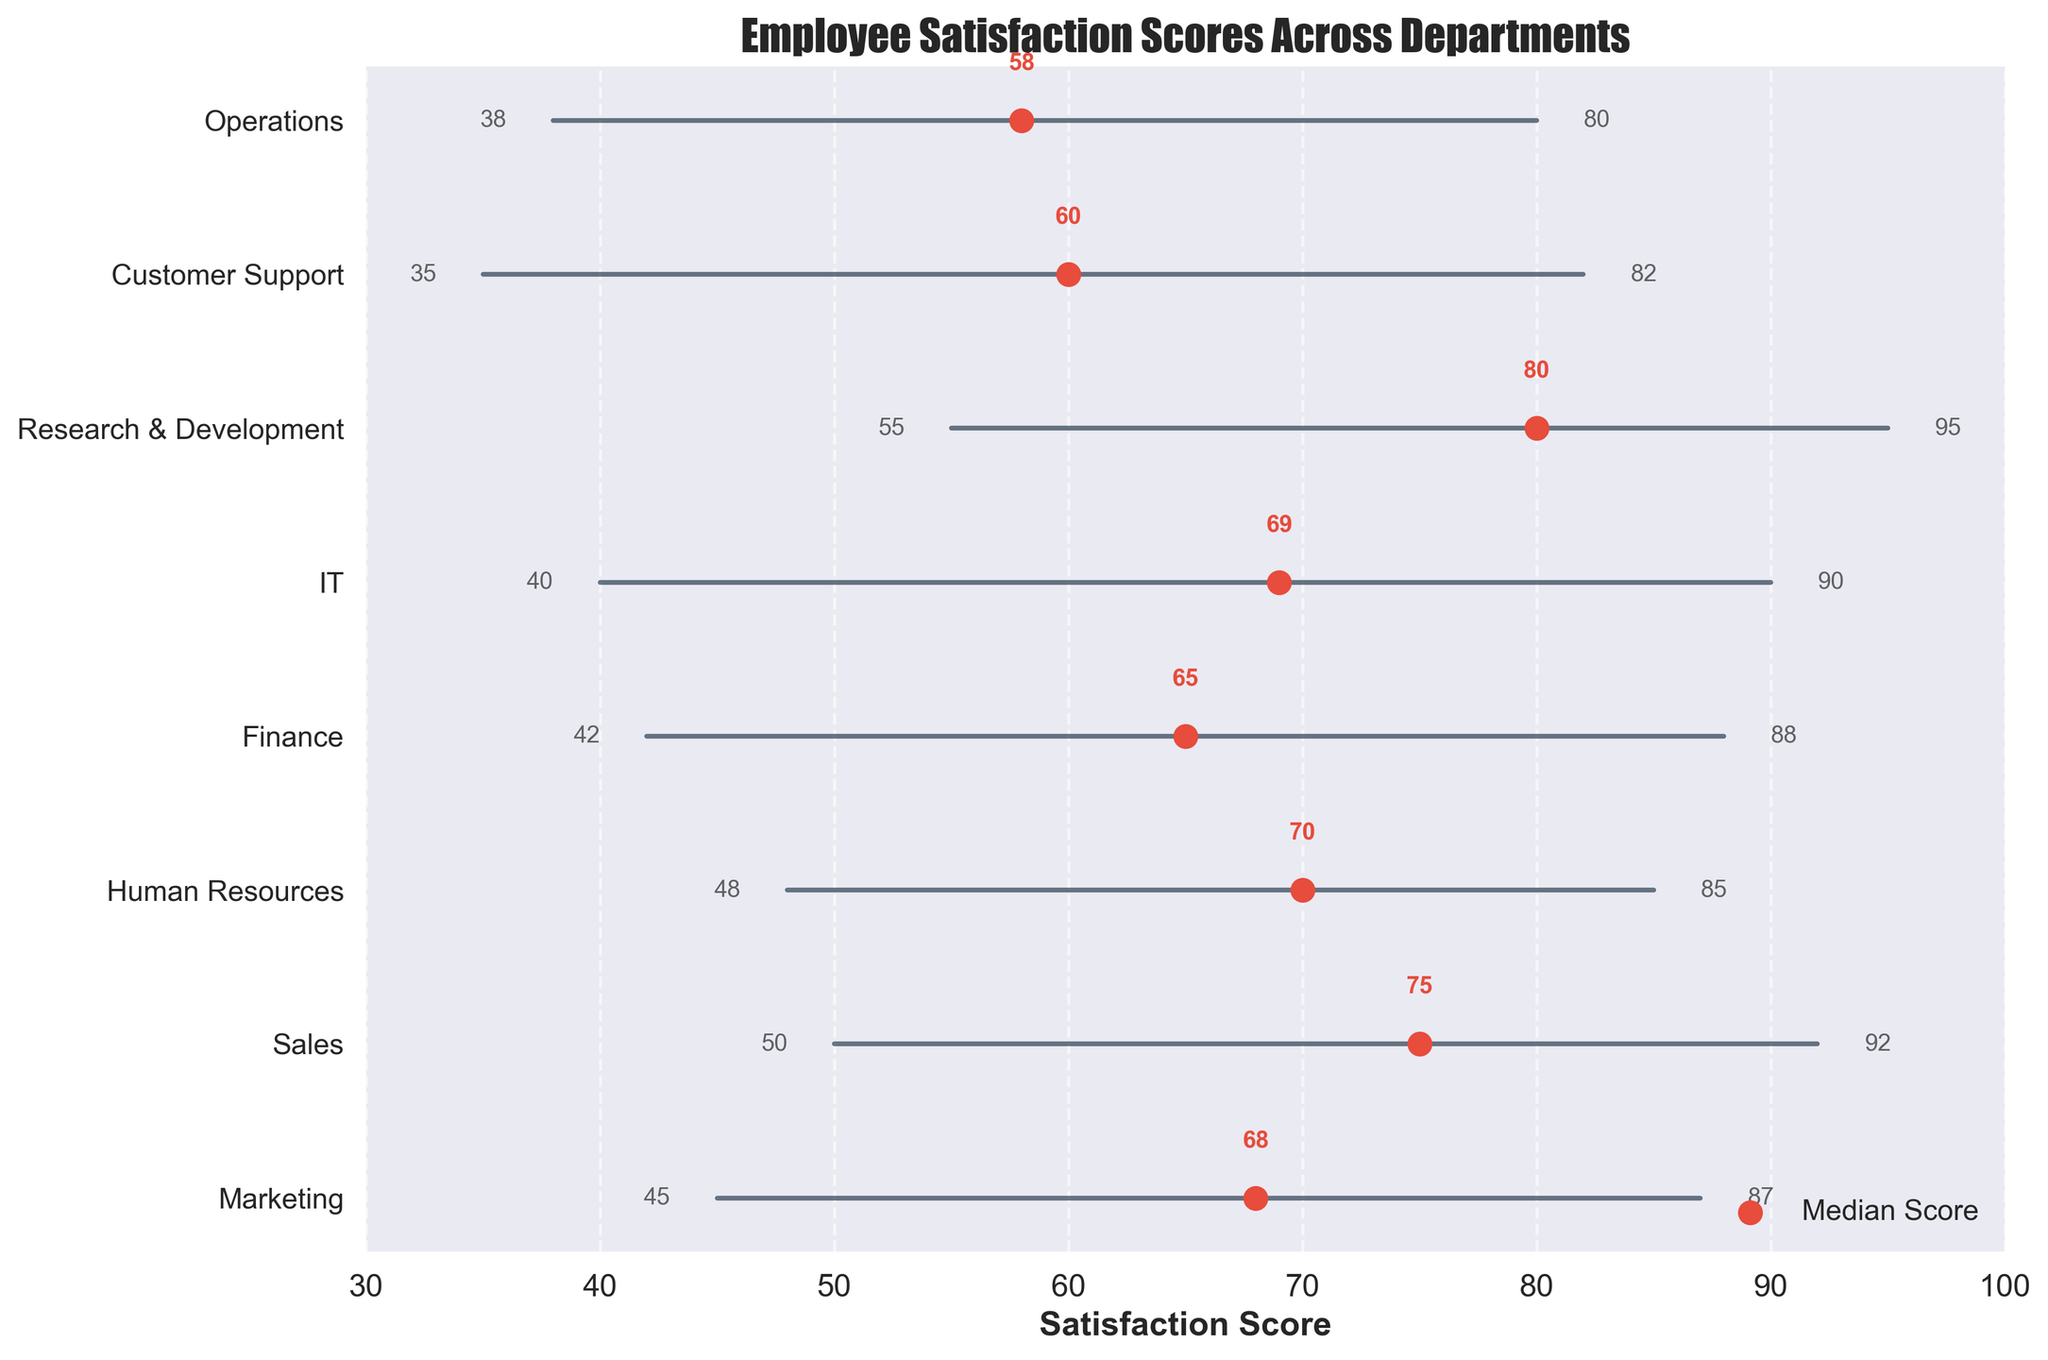Which department has the highest median employee satisfaction score? The department with the highest median score is the one whose red dot (representing the median) is furthest to the right on the horizontal axis. The Research & Development department has the highest median score.
Answer: Research & Development What is the range of employee satisfaction scores in the Customer Support department? The range is calculated by subtracting the minimum score from the maximum score. For Customer Support, the minimum score is 35 and the maximum score is 82. Therefore, the range is 82 - 35 = 47.
Answer: 47 Which department shows the smallest range of employee satisfaction scores? To find the smallest range, locate the department with the shortest line. Human Resources has scores ranging from 48 to 85, giving a range of 85 - 48 = 37, which is the smallest range in the plot.
Answer: Human Resources How does the median score of the IT department compare to that of the Sales department? The IT department's median score is 69, and the Sales department's median score is 75. Comparing the two, the IT department's median is lower than Sales by 75 - 69 = 6 points.
Answer: The IT department's median score is 6 points lower than Sales' What are the scores at the range endpoints for the Operations department? The scores at the range endpoints are directly read from the beginning and end of the line for Operations. The minimum score is 38 and the maximum score is 80.
Answer: 38 (min), 80 (max) Which department has the median score closest to 70? Locate the departments whose median score is marked close to 70. Both Human Resources and IT have median scores close to 70, with IT at 69 and Human Resources exactly at 70, making Human Resources the closest.
Answer: Human Resources Are the ranges of scores wider in customer-facing departments (Sales, Marketing, Customer Support) compared to back-office departments (Finance, IT, Operations)? Check the length of lines for each department mentioned. The highest ranges for customer-facing are 42 (Sales), 42 (Marketing), and 47 (Customer Support). For back-office: 46 (Finance), 50 (IT), and 42 (Operations). The ranges are relatively similar, with no significant difference.
Answer: Similar What is the average of the median scores for the Marketing and Finance departments? To find the average, add the median scores of the two departments and then divide by 2. Marketing's median is 68 and Finance's median is 65. (68 + 65) / 2 = 66.5.
Answer: 66.5 